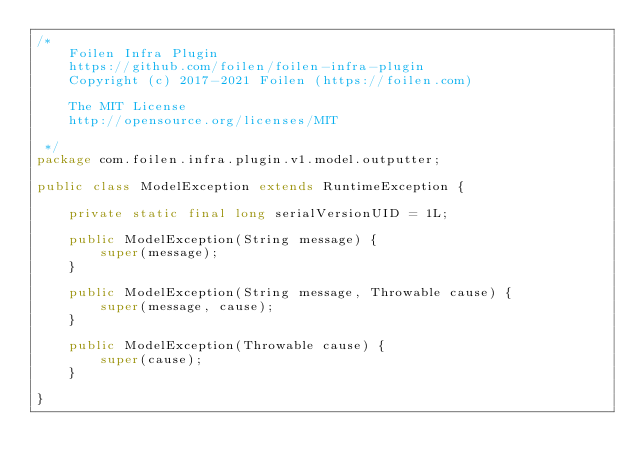Convert code to text. <code><loc_0><loc_0><loc_500><loc_500><_Java_>/*
    Foilen Infra Plugin
    https://github.com/foilen/foilen-infra-plugin
    Copyright (c) 2017-2021 Foilen (https://foilen.com)

    The MIT License
    http://opensource.org/licenses/MIT

 */
package com.foilen.infra.plugin.v1.model.outputter;

public class ModelException extends RuntimeException {

    private static final long serialVersionUID = 1L;

    public ModelException(String message) {
        super(message);
    }

    public ModelException(String message, Throwable cause) {
        super(message, cause);
    }

    public ModelException(Throwable cause) {
        super(cause);
    }

}
</code> 